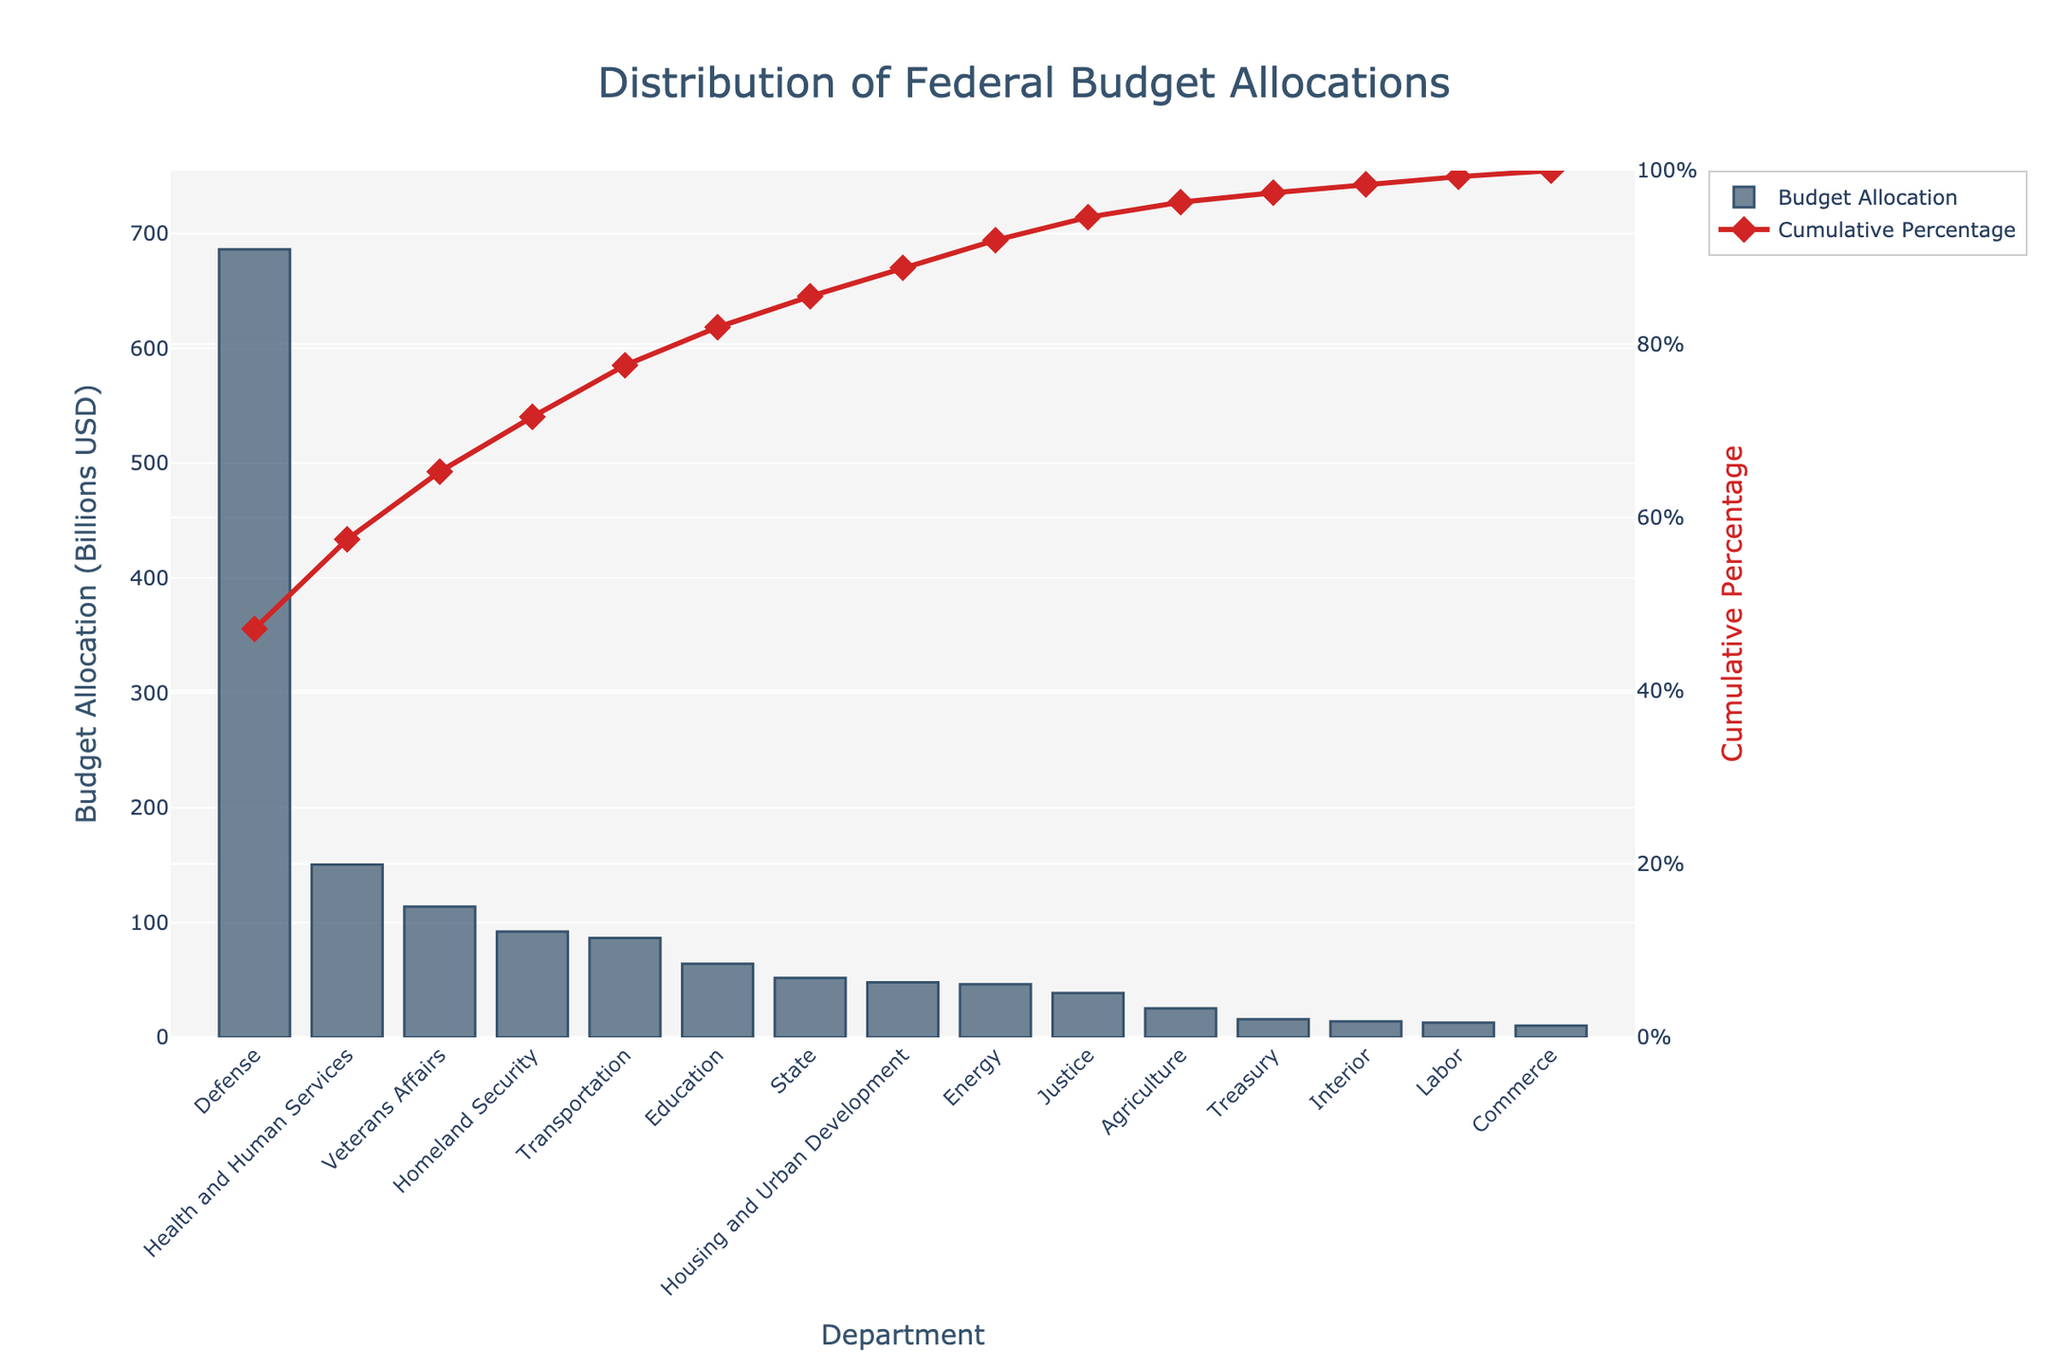What is the title of the Pareto chart? The title of the chart is usually placed at the top and is written in a larger font size for emphasis. In this chart, the title reads "Distribution of Federal Budget Allocations".
Answer: Distribution of Federal Budget Allocations Which department has the highest budget allocation? The bars in the Pareto chart represent the budget allocation for each department. The tallest bar belongs to the Department of Defense, indicating the highest budget allocation.
Answer: Defense What is the total budget allocation for the Department of Health and Human Services and the Department of Veterans Affairs? From the chart, identify the budget allocation for the Department of Health and Human Services (150.4) and the Department of Veterans Affairs (113.8). Summing these values gives 150.4 + 113.8 = 264.2 billion USD.
Answer: 264.2 billion USD Which departments have a budget allocation greater than 50 billion USD? Reviewing the bars in the chart, the departments with budget allocations greater than 50 billion USD are Defense, Health and Human Services, Veterans Affairs, Homeland Security, Transportation, Education, State, and Housing and Urban Development.
Answer: Defense, Health and Human Services, Veterans Affairs, Homeland Security, Transportation, Education, State, Housing and Urban Development What is the cumulative percentage of budget allocation up to the Department of Homeland Security? The cumulative percentage line shows the aggregated budget allocation percentages. To find the cumulative percentage up to Homeland Security, look at the point on the cumulative percentage line corresponding to the Homeland Security bar. It is approximately 80%.
Answer: Approximately 80% Which department is closest to contributing 25% of the cumulative budget allocation? The cumulative percentage line indicates the cumulative budget share. The department closest to the 25% mark on this line is Health and Human Services.
Answer: Health and Human Services By how much does the budget allocation of the Department of Energy and the Department of Commerce differ? From the chart, the Department of Energy has an allocation of 46.3 billion USD and the Department of Commerce has 10.2 billion USD. The difference is 46.3 - 10.2 = 36.1 billion USD.
Answer: 36.1 billion USD How many departments have a budget allocation of less than 20 billion USD? Identify the bars that are less than the 20 billion USD mark. The departments that meet this criterion are Treasury, Interior, Labor, and Commerce, totaling four departments.
Answer: 4 What percentage of the total budget allocation do the three largest budget departments account for? The three largest budget departments are Defense (686.1), Health and Human Services (150.4), and Veterans Affairs (113.8). Add their allocations and divide by the total budget, then multiply by 100 to find the percentage: [(686.1 + 150.4 + 113.8) / Total Budget] * 100.
Answer: 72.74% Which department's budget allocation is represented by the smallest bar, and what is its allocation amount? The smallest bar in the Pareto chart represents the Department of Commerce with a budget allocation amount of 10.2 billion USD.
Answer: Commerce, 10.2 billion USD 